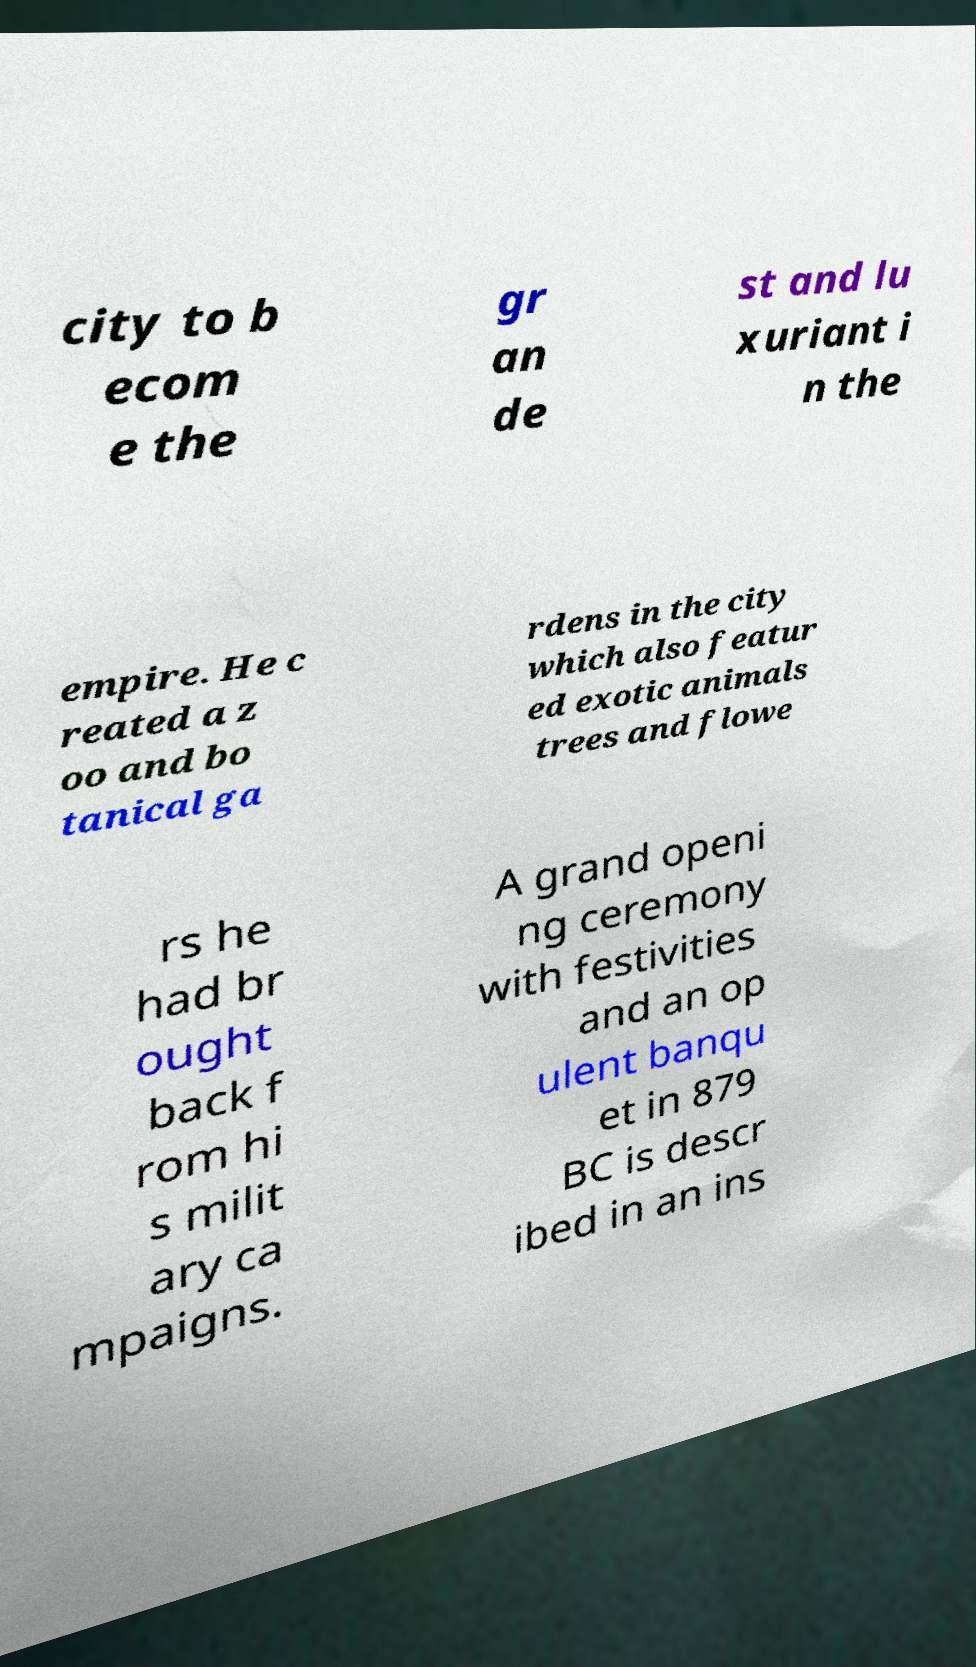I need the written content from this picture converted into text. Can you do that? city to b ecom e the gr an de st and lu xuriant i n the empire. He c reated a z oo and bo tanical ga rdens in the city which also featur ed exotic animals trees and flowe rs he had br ought back f rom hi s milit ary ca mpaigns. A grand openi ng ceremony with festivities and an op ulent banqu et in 879 BC is descr ibed in an ins 